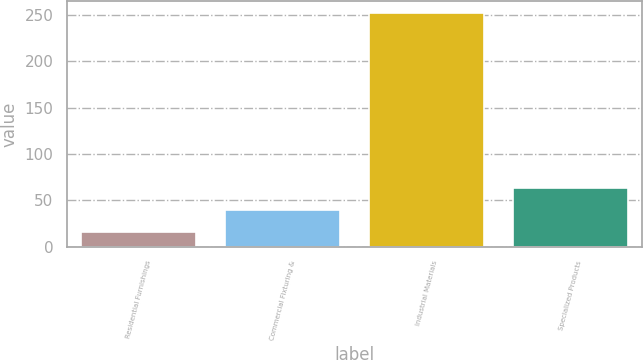Convert chart to OTSL. <chart><loc_0><loc_0><loc_500><loc_500><bar_chart><fcel>Residential Furnishings<fcel>Commercial Fixturing &<fcel>Industrial Materials<fcel>Specialized Products<nl><fcel>15.6<fcel>39.3<fcel>252.6<fcel>63<nl></chart> 